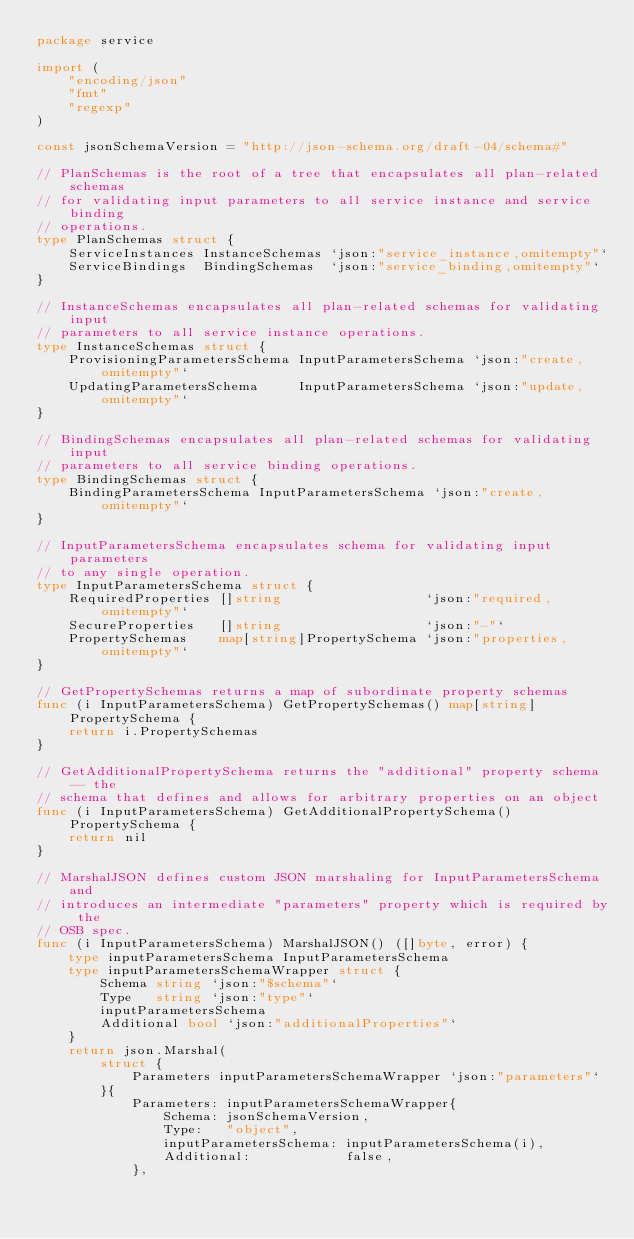<code> <loc_0><loc_0><loc_500><loc_500><_Go_>package service

import (
	"encoding/json"
	"fmt"
	"regexp"
)

const jsonSchemaVersion = "http://json-schema.org/draft-04/schema#"

// PlanSchemas is the root of a tree that encapsulates all plan-related schemas
// for validating input parameters to all service instance and service binding
// operations.
type PlanSchemas struct {
	ServiceInstances InstanceSchemas `json:"service_instance,omitempty"`
	ServiceBindings  BindingSchemas  `json:"service_binding,omitempty"`
}

// InstanceSchemas encapsulates all plan-related schemas for validating input
// parameters to all service instance operations.
type InstanceSchemas struct {
	ProvisioningParametersSchema InputParametersSchema `json:"create,omitempty"`
	UpdatingParametersSchema     InputParametersSchema `json:"update,omitempty"`
}

// BindingSchemas encapsulates all plan-related schemas for validating input
// parameters to all service binding operations.
type BindingSchemas struct {
	BindingParametersSchema InputParametersSchema `json:"create,omitempty"`
}

// InputParametersSchema encapsulates schema for validating input parameters
// to any single operation.
type InputParametersSchema struct {
	RequiredProperties []string                  `json:"required,omitempty"`
	SecureProperties   []string                  `json:"-"`
	PropertySchemas    map[string]PropertySchema `json:"properties,omitempty"`
}

// GetPropertySchemas returns a map of subordinate property schemas
func (i InputParametersSchema) GetPropertySchemas() map[string]PropertySchema {
	return i.PropertySchemas
}

// GetAdditionalPropertySchema returns the "additional" property schema-- the
// schema that defines and allows for arbitrary properties on an object
func (i InputParametersSchema) GetAdditionalPropertySchema() PropertySchema {
	return nil
}

// MarshalJSON defines custom JSON marshaling for InputParametersSchema and
// introduces an intermediate "parameters" property which is required by the
// OSB spec.
func (i InputParametersSchema) MarshalJSON() ([]byte, error) {
	type inputParametersSchema InputParametersSchema
	type inputParametersSchemaWrapper struct {
		Schema string `json:"$schema"`
		Type   string `json:"type"`
		inputParametersSchema
		Additional bool `json:"additionalProperties"`
	}
	return json.Marshal(
		struct {
			Parameters inputParametersSchemaWrapper `json:"parameters"`
		}{
			Parameters: inputParametersSchemaWrapper{
				Schema: jsonSchemaVersion,
				Type:   "object",
				inputParametersSchema: inputParametersSchema(i),
				Additional:            false,
			},</code> 